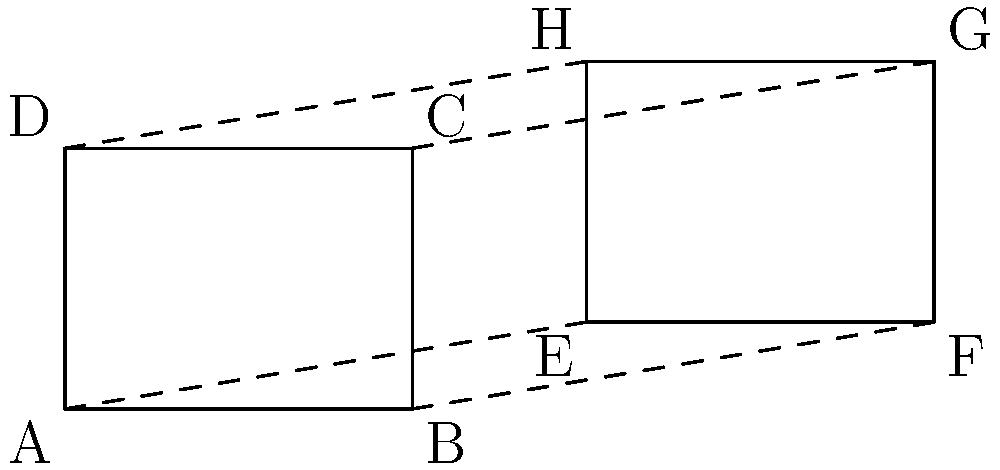Two rectangular solar panel arrays ABCD and EFGH are shown in the diagram. If array ABCD has dimensions of 4 meters by 3 meters, and array EFGH is congruent to ABCD but translated and rotated, what is the area of the quadrilateral formed by connecting the corresponding vertices of the two arrays (i.e., AEBF)? Let's approach this step-by-step:

1) First, we need to understand what congruence means. Congruent shapes have the same size and shape, but can be in different positions or orientations.

2) Given that ABCD is 4m by 3m, its area is 12 square meters. EFGH, being congruent, also has an area of 12 square meters.

3) The quadrilateral AEBF is formed by connecting the corresponding vertices of the two arrays. This forms a parallelogram.

4) In a parallelogram, opposite sides are parallel and equal in length. So, AE = BF and AB = EF.

5) The area of a parallelogram is given by the formula: $A = bh$, where $b$ is the base and $h$ is the height (perpendicular distance between the base and its opposite side).

6) In this case, we can use AB as the base, which we know is 4m.

7) The height of the parallelogram is the perpendicular distance between AB and EF. This is equal to the vertical displacement of array EFGH from ABCD, which is 1m (as seen from the diagram).

8) Therefore, the area of parallelogram AEBF is:

   $A = bh = 4m \times 1m = 4$ square meters

Thus, the area of the quadrilateral AEBF is 4 square meters.
Answer: 4 square meters 